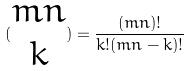<formula> <loc_0><loc_0><loc_500><loc_500>( \begin{matrix} m n \\ k \end{matrix} ) = \frac { ( m n ) ! } { k ! ( m n - k ) ! }</formula> 